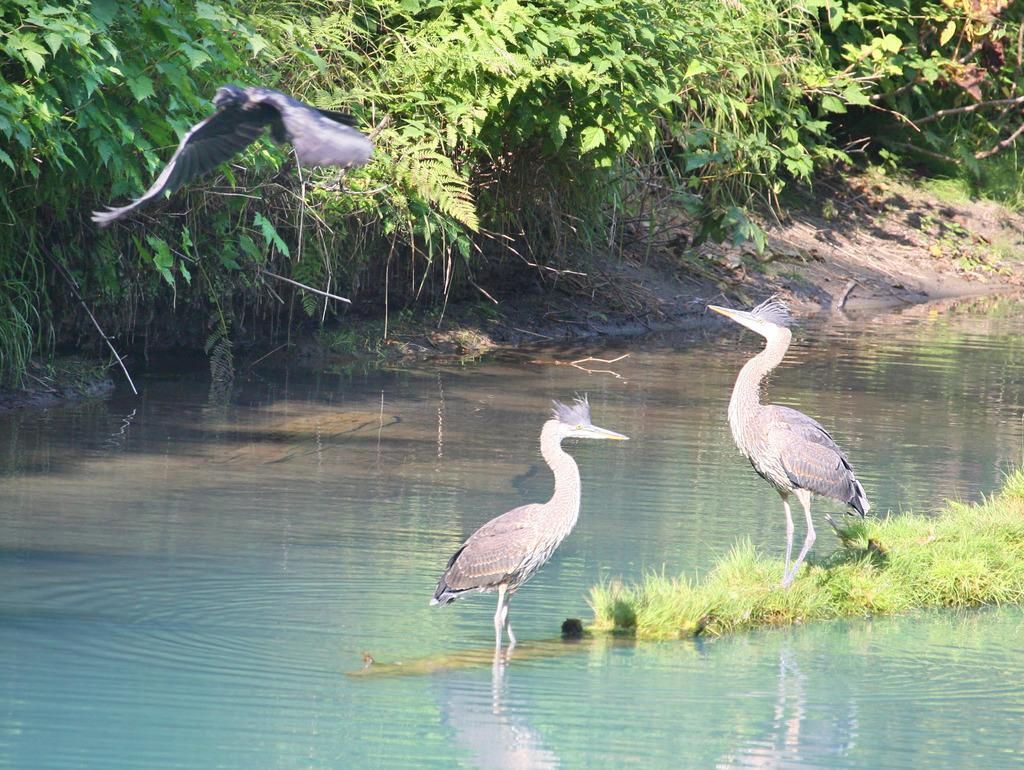What animals can be seen in the image? There are two birds on the water in the image. What type of vegetation is visible in the image? Grass and plants are visible in the image. What is one bird doing in the image? One bird is flying in the air with its wings. What type of wool can be seen on the birds in the image? There is no wool present on the birds in the image; they are birds and do not have wool. 